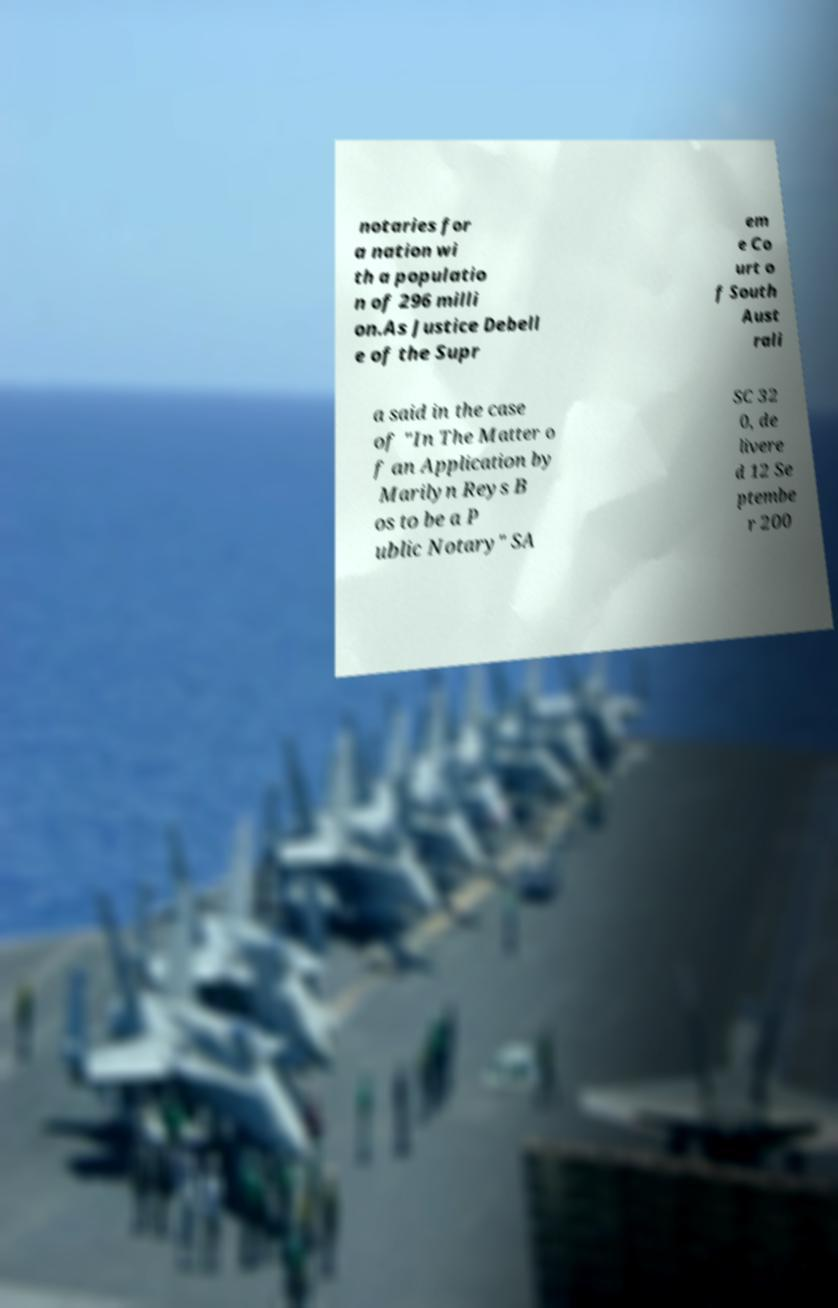Please read and relay the text visible in this image. What does it say? notaries for a nation wi th a populatio n of 296 milli on.As Justice Debell e of the Supr em e Co urt o f South Aust rali a said in the case of "In The Matter o f an Application by Marilyn Reys B os to be a P ublic Notary" SA SC 32 0, de livere d 12 Se ptembe r 200 